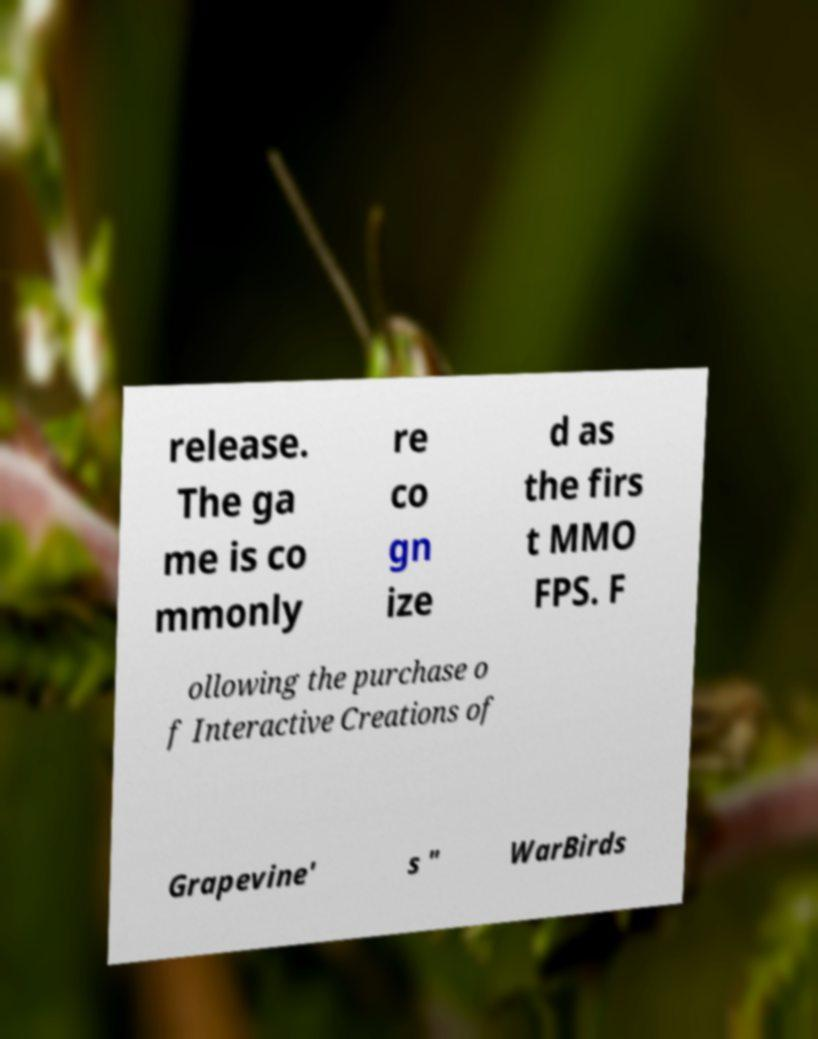Can you accurately transcribe the text from the provided image for me? release. The ga me is co mmonly re co gn ize d as the firs t MMO FPS. F ollowing the purchase o f Interactive Creations of Grapevine' s " WarBirds 